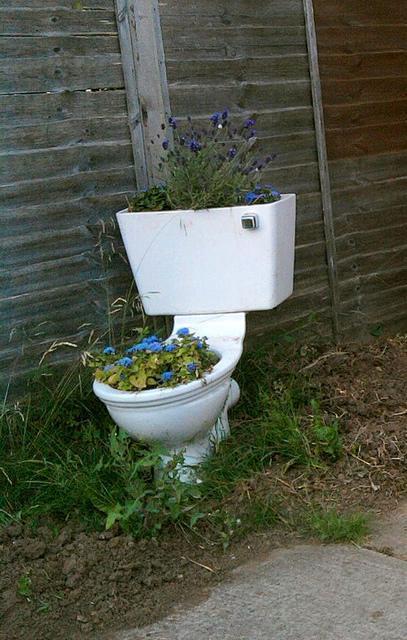How many potted plants do you see?
Give a very brief answer. 2. 